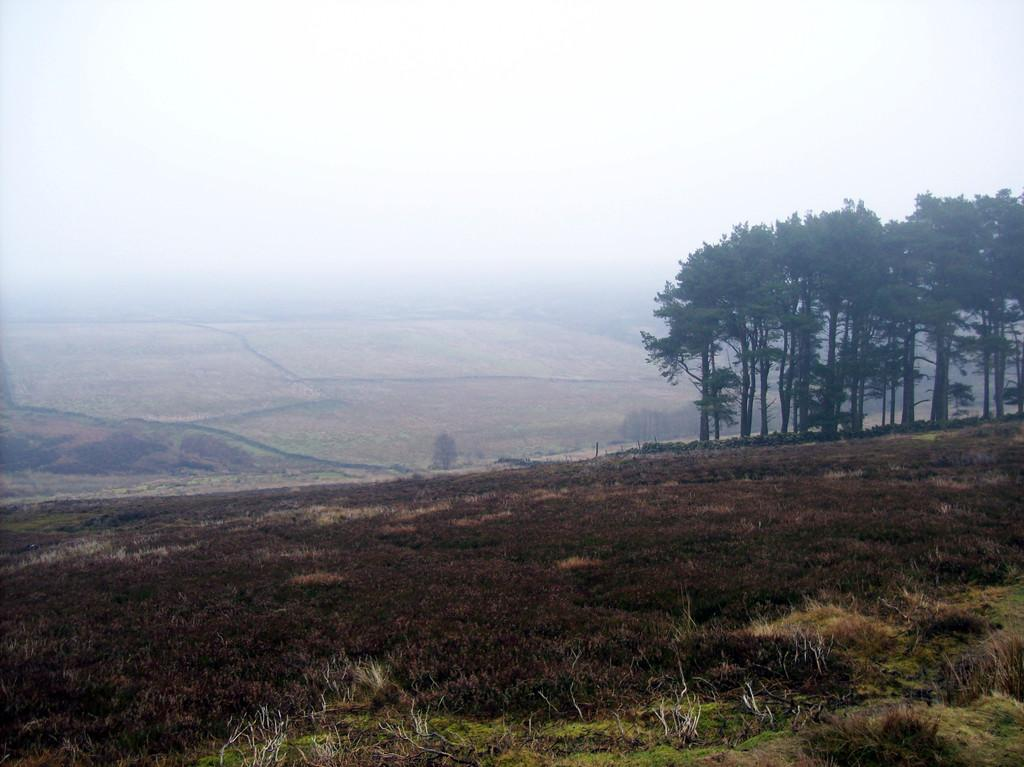What type of vegetation can be seen in the image? There is grass, plants, and trees in the image. What type of landscape feature is present in the image? There are mountains in the image. What is the weather condition in the image? There is fog in the image. What type of human activity can be seen in the image? There are farms in the image. What part of the natural environment is visible in the image? The sky is visible in the image. Can you determine the time of day the image was taken? The image is likely taken during the day, as the sky is visible. Can you see any steam coming from the boy's ears in the image? There is no boy present in the image, and therefore no steam coming from his ears. What type of power source is used to generate electricity in the image? There is no power source or electricity generation visible in the image. 